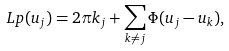Convert formula to latex. <formula><loc_0><loc_0><loc_500><loc_500>L p ( u _ { j } ) = 2 \pi k _ { j } + \sum _ { k \neq j } \Phi ( u _ { j } - u _ { k } ) ,</formula> 